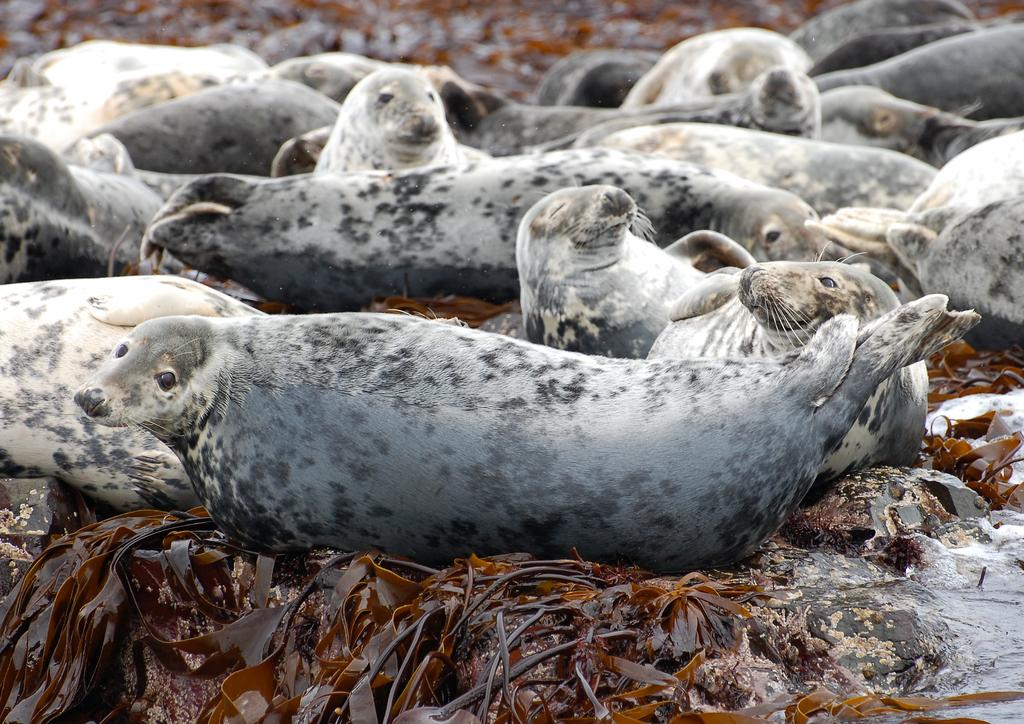What animals can be seen on the rocks in the image? There are harbor seals on the rocks in the image. What type of vegetation is present in the image? There are leaves and stems in the image. What is visible behind the rocks? There is water visible behind the rocks. What arithmetic problem is the harbor seal solving on the rocks? Harbor seals do not solve arithmetic problems; they are animals and not capable of such tasks. 